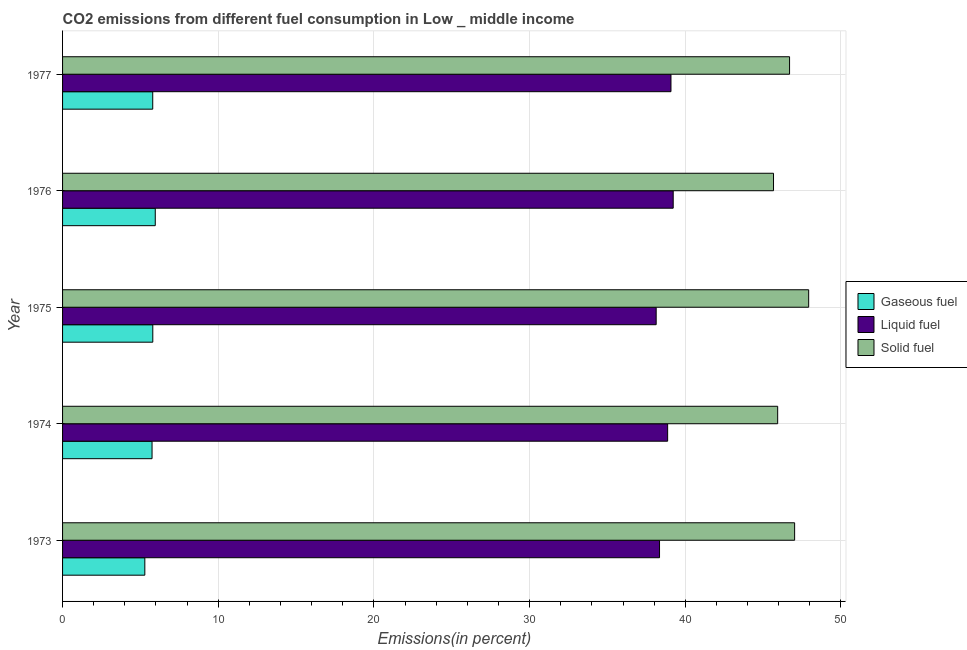How many groups of bars are there?
Provide a succinct answer. 5. Are the number of bars per tick equal to the number of legend labels?
Keep it short and to the point. Yes. Are the number of bars on each tick of the Y-axis equal?
Provide a succinct answer. Yes. How many bars are there on the 5th tick from the top?
Make the answer very short. 3. What is the label of the 1st group of bars from the top?
Ensure brevity in your answer.  1977. In how many cases, is the number of bars for a given year not equal to the number of legend labels?
Your answer should be very brief. 0. What is the percentage of solid fuel emission in 1976?
Give a very brief answer. 45.67. Across all years, what is the maximum percentage of solid fuel emission?
Make the answer very short. 47.92. Across all years, what is the minimum percentage of liquid fuel emission?
Offer a very short reply. 38.13. In which year was the percentage of solid fuel emission maximum?
Provide a succinct answer. 1975. In which year was the percentage of liquid fuel emission minimum?
Your response must be concise. 1975. What is the total percentage of gaseous fuel emission in the graph?
Offer a terse response. 28.57. What is the difference between the percentage of liquid fuel emission in 1973 and that in 1976?
Your answer should be very brief. -0.88. What is the difference between the percentage of solid fuel emission in 1975 and the percentage of gaseous fuel emission in 1977?
Keep it short and to the point. 42.13. What is the average percentage of liquid fuel emission per year?
Give a very brief answer. 38.73. In the year 1975, what is the difference between the percentage of solid fuel emission and percentage of liquid fuel emission?
Make the answer very short. 9.79. In how many years, is the percentage of gaseous fuel emission greater than 42 %?
Give a very brief answer. 0. What is the ratio of the percentage of solid fuel emission in 1973 to that in 1974?
Ensure brevity in your answer.  1.02. Is the difference between the percentage of gaseous fuel emission in 1973 and 1977 greater than the difference between the percentage of solid fuel emission in 1973 and 1977?
Ensure brevity in your answer.  No. What is the difference between the highest and the second highest percentage of liquid fuel emission?
Offer a terse response. 0.14. What is the difference between the highest and the lowest percentage of solid fuel emission?
Offer a very short reply. 2.26. What does the 2nd bar from the top in 1977 represents?
Make the answer very short. Liquid fuel. What does the 1st bar from the bottom in 1975 represents?
Make the answer very short. Gaseous fuel. Is it the case that in every year, the sum of the percentage of gaseous fuel emission and percentage of liquid fuel emission is greater than the percentage of solid fuel emission?
Keep it short and to the point. No. How many bars are there?
Make the answer very short. 15. Are the values on the major ticks of X-axis written in scientific E-notation?
Provide a short and direct response. No. Does the graph contain any zero values?
Your response must be concise. No. Does the graph contain grids?
Make the answer very short. Yes. Where does the legend appear in the graph?
Provide a succinct answer. Center right. How are the legend labels stacked?
Offer a terse response. Vertical. What is the title of the graph?
Offer a very short reply. CO2 emissions from different fuel consumption in Low _ middle income. Does "Primary education" appear as one of the legend labels in the graph?
Offer a terse response. No. What is the label or title of the X-axis?
Provide a short and direct response. Emissions(in percent). What is the Emissions(in percent) in Gaseous fuel in 1973?
Ensure brevity in your answer.  5.28. What is the Emissions(in percent) in Liquid fuel in 1973?
Your answer should be compact. 38.35. What is the Emissions(in percent) in Solid fuel in 1973?
Offer a very short reply. 47.02. What is the Emissions(in percent) in Gaseous fuel in 1974?
Give a very brief answer. 5.75. What is the Emissions(in percent) of Liquid fuel in 1974?
Make the answer very short. 38.87. What is the Emissions(in percent) in Solid fuel in 1974?
Keep it short and to the point. 45.93. What is the Emissions(in percent) of Gaseous fuel in 1975?
Your answer should be compact. 5.8. What is the Emissions(in percent) of Liquid fuel in 1975?
Keep it short and to the point. 38.13. What is the Emissions(in percent) of Solid fuel in 1975?
Ensure brevity in your answer.  47.92. What is the Emissions(in percent) in Gaseous fuel in 1976?
Ensure brevity in your answer.  5.95. What is the Emissions(in percent) of Liquid fuel in 1976?
Provide a short and direct response. 39.22. What is the Emissions(in percent) in Solid fuel in 1976?
Your answer should be very brief. 45.67. What is the Emissions(in percent) of Gaseous fuel in 1977?
Provide a succinct answer. 5.79. What is the Emissions(in percent) in Liquid fuel in 1977?
Keep it short and to the point. 39.08. What is the Emissions(in percent) in Solid fuel in 1977?
Offer a terse response. 46.7. Across all years, what is the maximum Emissions(in percent) of Gaseous fuel?
Offer a terse response. 5.95. Across all years, what is the maximum Emissions(in percent) of Liquid fuel?
Your response must be concise. 39.22. Across all years, what is the maximum Emissions(in percent) of Solid fuel?
Provide a short and direct response. 47.92. Across all years, what is the minimum Emissions(in percent) in Gaseous fuel?
Make the answer very short. 5.28. Across all years, what is the minimum Emissions(in percent) in Liquid fuel?
Offer a terse response. 38.13. Across all years, what is the minimum Emissions(in percent) in Solid fuel?
Offer a terse response. 45.67. What is the total Emissions(in percent) in Gaseous fuel in the graph?
Provide a succinct answer. 28.57. What is the total Emissions(in percent) in Liquid fuel in the graph?
Your response must be concise. 193.64. What is the total Emissions(in percent) of Solid fuel in the graph?
Provide a succinct answer. 233.24. What is the difference between the Emissions(in percent) in Gaseous fuel in 1973 and that in 1974?
Ensure brevity in your answer.  -0.46. What is the difference between the Emissions(in percent) in Liquid fuel in 1973 and that in 1974?
Offer a very short reply. -0.52. What is the difference between the Emissions(in percent) of Solid fuel in 1973 and that in 1974?
Keep it short and to the point. 1.09. What is the difference between the Emissions(in percent) of Gaseous fuel in 1973 and that in 1975?
Provide a succinct answer. -0.51. What is the difference between the Emissions(in percent) in Liquid fuel in 1973 and that in 1975?
Provide a short and direct response. 0.22. What is the difference between the Emissions(in percent) in Solid fuel in 1973 and that in 1975?
Ensure brevity in your answer.  -0.9. What is the difference between the Emissions(in percent) in Gaseous fuel in 1973 and that in 1976?
Give a very brief answer. -0.67. What is the difference between the Emissions(in percent) of Liquid fuel in 1973 and that in 1976?
Provide a short and direct response. -0.88. What is the difference between the Emissions(in percent) of Solid fuel in 1973 and that in 1976?
Your answer should be compact. 1.36. What is the difference between the Emissions(in percent) of Gaseous fuel in 1973 and that in 1977?
Your response must be concise. -0.51. What is the difference between the Emissions(in percent) of Liquid fuel in 1973 and that in 1977?
Ensure brevity in your answer.  -0.73. What is the difference between the Emissions(in percent) of Solid fuel in 1973 and that in 1977?
Offer a terse response. 0.33. What is the difference between the Emissions(in percent) in Gaseous fuel in 1974 and that in 1975?
Give a very brief answer. -0.05. What is the difference between the Emissions(in percent) of Liquid fuel in 1974 and that in 1975?
Make the answer very short. 0.74. What is the difference between the Emissions(in percent) of Solid fuel in 1974 and that in 1975?
Provide a succinct answer. -1.99. What is the difference between the Emissions(in percent) of Gaseous fuel in 1974 and that in 1976?
Make the answer very short. -0.21. What is the difference between the Emissions(in percent) in Liquid fuel in 1974 and that in 1976?
Provide a short and direct response. -0.36. What is the difference between the Emissions(in percent) in Solid fuel in 1974 and that in 1976?
Keep it short and to the point. 0.27. What is the difference between the Emissions(in percent) in Gaseous fuel in 1974 and that in 1977?
Give a very brief answer. -0.04. What is the difference between the Emissions(in percent) of Liquid fuel in 1974 and that in 1977?
Your answer should be compact. -0.21. What is the difference between the Emissions(in percent) in Solid fuel in 1974 and that in 1977?
Keep it short and to the point. -0.76. What is the difference between the Emissions(in percent) in Gaseous fuel in 1975 and that in 1976?
Your answer should be very brief. -0.16. What is the difference between the Emissions(in percent) in Liquid fuel in 1975 and that in 1976?
Give a very brief answer. -1.09. What is the difference between the Emissions(in percent) in Solid fuel in 1975 and that in 1976?
Your answer should be very brief. 2.26. What is the difference between the Emissions(in percent) of Gaseous fuel in 1975 and that in 1977?
Offer a very short reply. 0. What is the difference between the Emissions(in percent) in Liquid fuel in 1975 and that in 1977?
Offer a terse response. -0.95. What is the difference between the Emissions(in percent) of Solid fuel in 1975 and that in 1977?
Make the answer very short. 1.23. What is the difference between the Emissions(in percent) of Gaseous fuel in 1976 and that in 1977?
Provide a succinct answer. 0.16. What is the difference between the Emissions(in percent) of Liquid fuel in 1976 and that in 1977?
Your response must be concise. 0.14. What is the difference between the Emissions(in percent) of Solid fuel in 1976 and that in 1977?
Provide a short and direct response. -1.03. What is the difference between the Emissions(in percent) of Gaseous fuel in 1973 and the Emissions(in percent) of Liquid fuel in 1974?
Offer a very short reply. -33.58. What is the difference between the Emissions(in percent) in Gaseous fuel in 1973 and the Emissions(in percent) in Solid fuel in 1974?
Ensure brevity in your answer.  -40.65. What is the difference between the Emissions(in percent) of Liquid fuel in 1973 and the Emissions(in percent) of Solid fuel in 1974?
Your answer should be compact. -7.59. What is the difference between the Emissions(in percent) in Gaseous fuel in 1973 and the Emissions(in percent) in Liquid fuel in 1975?
Keep it short and to the point. -32.85. What is the difference between the Emissions(in percent) in Gaseous fuel in 1973 and the Emissions(in percent) in Solid fuel in 1975?
Your response must be concise. -42.64. What is the difference between the Emissions(in percent) in Liquid fuel in 1973 and the Emissions(in percent) in Solid fuel in 1975?
Your answer should be very brief. -9.58. What is the difference between the Emissions(in percent) of Gaseous fuel in 1973 and the Emissions(in percent) of Liquid fuel in 1976?
Make the answer very short. -33.94. What is the difference between the Emissions(in percent) in Gaseous fuel in 1973 and the Emissions(in percent) in Solid fuel in 1976?
Provide a short and direct response. -40.38. What is the difference between the Emissions(in percent) of Liquid fuel in 1973 and the Emissions(in percent) of Solid fuel in 1976?
Offer a terse response. -7.32. What is the difference between the Emissions(in percent) in Gaseous fuel in 1973 and the Emissions(in percent) in Liquid fuel in 1977?
Offer a terse response. -33.8. What is the difference between the Emissions(in percent) of Gaseous fuel in 1973 and the Emissions(in percent) of Solid fuel in 1977?
Your answer should be compact. -41.41. What is the difference between the Emissions(in percent) of Liquid fuel in 1973 and the Emissions(in percent) of Solid fuel in 1977?
Provide a succinct answer. -8.35. What is the difference between the Emissions(in percent) of Gaseous fuel in 1974 and the Emissions(in percent) of Liquid fuel in 1975?
Your answer should be very brief. -32.38. What is the difference between the Emissions(in percent) of Gaseous fuel in 1974 and the Emissions(in percent) of Solid fuel in 1975?
Provide a short and direct response. -42.18. What is the difference between the Emissions(in percent) in Liquid fuel in 1974 and the Emissions(in percent) in Solid fuel in 1975?
Ensure brevity in your answer.  -9.06. What is the difference between the Emissions(in percent) of Gaseous fuel in 1974 and the Emissions(in percent) of Liquid fuel in 1976?
Provide a short and direct response. -33.48. What is the difference between the Emissions(in percent) in Gaseous fuel in 1974 and the Emissions(in percent) in Solid fuel in 1976?
Offer a very short reply. -39.92. What is the difference between the Emissions(in percent) of Liquid fuel in 1974 and the Emissions(in percent) of Solid fuel in 1976?
Offer a terse response. -6.8. What is the difference between the Emissions(in percent) of Gaseous fuel in 1974 and the Emissions(in percent) of Liquid fuel in 1977?
Provide a succinct answer. -33.33. What is the difference between the Emissions(in percent) of Gaseous fuel in 1974 and the Emissions(in percent) of Solid fuel in 1977?
Give a very brief answer. -40.95. What is the difference between the Emissions(in percent) in Liquid fuel in 1974 and the Emissions(in percent) in Solid fuel in 1977?
Ensure brevity in your answer.  -7.83. What is the difference between the Emissions(in percent) of Gaseous fuel in 1975 and the Emissions(in percent) of Liquid fuel in 1976?
Make the answer very short. -33.43. What is the difference between the Emissions(in percent) in Gaseous fuel in 1975 and the Emissions(in percent) in Solid fuel in 1976?
Provide a short and direct response. -39.87. What is the difference between the Emissions(in percent) of Liquid fuel in 1975 and the Emissions(in percent) of Solid fuel in 1976?
Keep it short and to the point. -7.54. What is the difference between the Emissions(in percent) in Gaseous fuel in 1975 and the Emissions(in percent) in Liquid fuel in 1977?
Make the answer very short. -33.28. What is the difference between the Emissions(in percent) of Gaseous fuel in 1975 and the Emissions(in percent) of Solid fuel in 1977?
Offer a terse response. -40.9. What is the difference between the Emissions(in percent) in Liquid fuel in 1975 and the Emissions(in percent) in Solid fuel in 1977?
Make the answer very short. -8.57. What is the difference between the Emissions(in percent) of Gaseous fuel in 1976 and the Emissions(in percent) of Liquid fuel in 1977?
Offer a very short reply. -33.13. What is the difference between the Emissions(in percent) of Gaseous fuel in 1976 and the Emissions(in percent) of Solid fuel in 1977?
Your response must be concise. -40.74. What is the difference between the Emissions(in percent) of Liquid fuel in 1976 and the Emissions(in percent) of Solid fuel in 1977?
Ensure brevity in your answer.  -7.47. What is the average Emissions(in percent) in Gaseous fuel per year?
Provide a short and direct response. 5.71. What is the average Emissions(in percent) in Liquid fuel per year?
Keep it short and to the point. 38.73. What is the average Emissions(in percent) in Solid fuel per year?
Offer a very short reply. 46.65. In the year 1973, what is the difference between the Emissions(in percent) of Gaseous fuel and Emissions(in percent) of Liquid fuel?
Your response must be concise. -33.06. In the year 1973, what is the difference between the Emissions(in percent) of Gaseous fuel and Emissions(in percent) of Solid fuel?
Ensure brevity in your answer.  -41.74. In the year 1973, what is the difference between the Emissions(in percent) of Liquid fuel and Emissions(in percent) of Solid fuel?
Make the answer very short. -8.68. In the year 1974, what is the difference between the Emissions(in percent) of Gaseous fuel and Emissions(in percent) of Liquid fuel?
Provide a short and direct response. -33.12. In the year 1974, what is the difference between the Emissions(in percent) in Gaseous fuel and Emissions(in percent) in Solid fuel?
Your answer should be compact. -40.19. In the year 1974, what is the difference between the Emissions(in percent) of Liquid fuel and Emissions(in percent) of Solid fuel?
Offer a very short reply. -7.07. In the year 1975, what is the difference between the Emissions(in percent) of Gaseous fuel and Emissions(in percent) of Liquid fuel?
Provide a short and direct response. -32.33. In the year 1975, what is the difference between the Emissions(in percent) in Gaseous fuel and Emissions(in percent) in Solid fuel?
Ensure brevity in your answer.  -42.13. In the year 1975, what is the difference between the Emissions(in percent) of Liquid fuel and Emissions(in percent) of Solid fuel?
Keep it short and to the point. -9.8. In the year 1976, what is the difference between the Emissions(in percent) of Gaseous fuel and Emissions(in percent) of Liquid fuel?
Ensure brevity in your answer.  -33.27. In the year 1976, what is the difference between the Emissions(in percent) in Gaseous fuel and Emissions(in percent) in Solid fuel?
Ensure brevity in your answer.  -39.71. In the year 1976, what is the difference between the Emissions(in percent) in Liquid fuel and Emissions(in percent) in Solid fuel?
Ensure brevity in your answer.  -6.44. In the year 1977, what is the difference between the Emissions(in percent) of Gaseous fuel and Emissions(in percent) of Liquid fuel?
Provide a succinct answer. -33.29. In the year 1977, what is the difference between the Emissions(in percent) of Gaseous fuel and Emissions(in percent) of Solid fuel?
Provide a short and direct response. -40.91. In the year 1977, what is the difference between the Emissions(in percent) of Liquid fuel and Emissions(in percent) of Solid fuel?
Your answer should be very brief. -7.62. What is the ratio of the Emissions(in percent) of Gaseous fuel in 1973 to that in 1974?
Ensure brevity in your answer.  0.92. What is the ratio of the Emissions(in percent) of Liquid fuel in 1973 to that in 1974?
Give a very brief answer. 0.99. What is the ratio of the Emissions(in percent) of Solid fuel in 1973 to that in 1974?
Offer a very short reply. 1.02. What is the ratio of the Emissions(in percent) in Gaseous fuel in 1973 to that in 1975?
Offer a terse response. 0.91. What is the ratio of the Emissions(in percent) in Liquid fuel in 1973 to that in 1975?
Make the answer very short. 1.01. What is the ratio of the Emissions(in percent) of Solid fuel in 1973 to that in 1975?
Make the answer very short. 0.98. What is the ratio of the Emissions(in percent) in Gaseous fuel in 1973 to that in 1976?
Provide a succinct answer. 0.89. What is the ratio of the Emissions(in percent) of Liquid fuel in 1973 to that in 1976?
Ensure brevity in your answer.  0.98. What is the ratio of the Emissions(in percent) in Solid fuel in 1973 to that in 1976?
Offer a terse response. 1.03. What is the ratio of the Emissions(in percent) of Gaseous fuel in 1973 to that in 1977?
Offer a very short reply. 0.91. What is the ratio of the Emissions(in percent) in Liquid fuel in 1973 to that in 1977?
Give a very brief answer. 0.98. What is the ratio of the Emissions(in percent) in Solid fuel in 1973 to that in 1977?
Offer a very short reply. 1.01. What is the ratio of the Emissions(in percent) in Liquid fuel in 1974 to that in 1975?
Your answer should be compact. 1.02. What is the ratio of the Emissions(in percent) of Solid fuel in 1974 to that in 1975?
Make the answer very short. 0.96. What is the ratio of the Emissions(in percent) of Gaseous fuel in 1974 to that in 1976?
Provide a succinct answer. 0.97. What is the ratio of the Emissions(in percent) of Liquid fuel in 1974 to that in 1976?
Provide a short and direct response. 0.99. What is the ratio of the Emissions(in percent) of Liquid fuel in 1974 to that in 1977?
Offer a very short reply. 0.99. What is the ratio of the Emissions(in percent) in Solid fuel in 1974 to that in 1977?
Make the answer very short. 0.98. What is the ratio of the Emissions(in percent) in Gaseous fuel in 1975 to that in 1976?
Provide a succinct answer. 0.97. What is the ratio of the Emissions(in percent) of Liquid fuel in 1975 to that in 1976?
Provide a succinct answer. 0.97. What is the ratio of the Emissions(in percent) of Solid fuel in 1975 to that in 1976?
Offer a very short reply. 1.05. What is the ratio of the Emissions(in percent) of Liquid fuel in 1975 to that in 1977?
Offer a very short reply. 0.98. What is the ratio of the Emissions(in percent) in Solid fuel in 1975 to that in 1977?
Provide a short and direct response. 1.03. What is the ratio of the Emissions(in percent) of Gaseous fuel in 1976 to that in 1977?
Your answer should be compact. 1.03. What is the ratio of the Emissions(in percent) in Liquid fuel in 1976 to that in 1977?
Give a very brief answer. 1. What is the ratio of the Emissions(in percent) of Solid fuel in 1976 to that in 1977?
Ensure brevity in your answer.  0.98. What is the difference between the highest and the second highest Emissions(in percent) in Gaseous fuel?
Give a very brief answer. 0.16. What is the difference between the highest and the second highest Emissions(in percent) of Liquid fuel?
Ensure brevity in your answer.  0.14. What is the difference between the highest and the second highest Emissions(in percent) of Solid fuel?
Offer a terse response. 0.9. What is the difference between the highest and the lowest Emissions(in percent) of Gaseous fuel?
Your answer should be compact. 0.67. What is the difference between the highest and the lowest Emissions(in percent) in Liquid fuel?
Your response must be concise. 1.09. What is the difference between the highest and the lowest Emissions(in percent) of Solid fuel?
Your response must be concise. 2.26. 